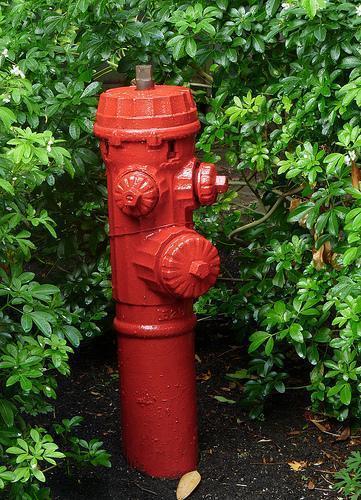How many hydrants are there?
Give a very brief answer. 1. How many large bolts on this fire hydrant are not painted red?
Give a very brief answer. 0. 